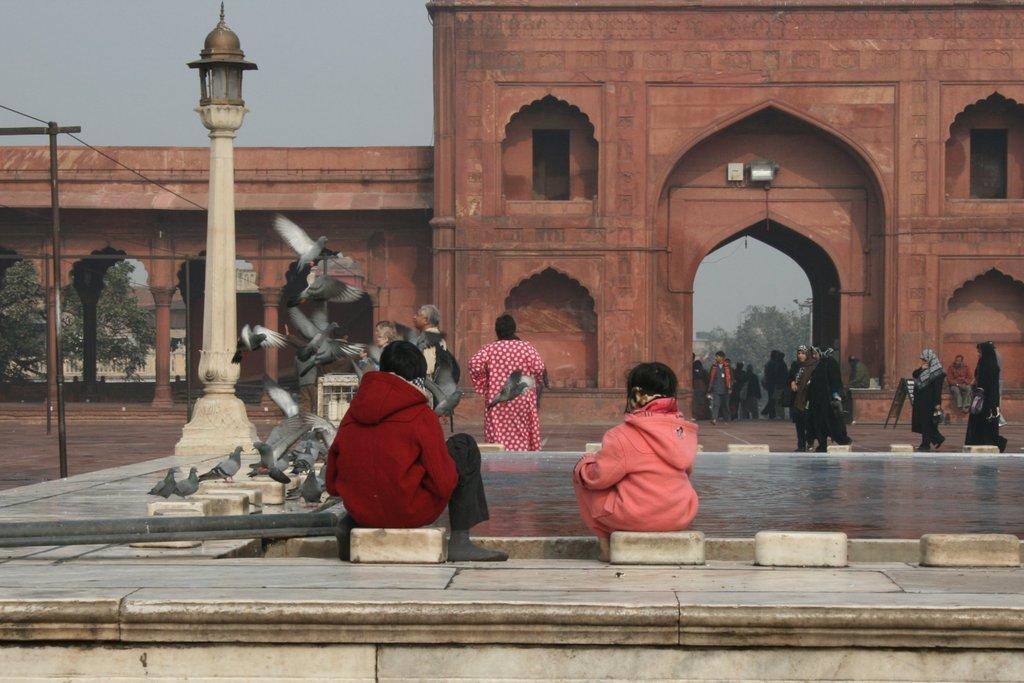Can you describe this image briefly? In this picture I can observe two members sitting on the white color stones. Both of them are wearing hoodies. On the left side there is a white color pillar and I can observe some pigeons. There are some people walking in this path. I can observe a monument which is in brown color. In the background there are trees and a sky. 